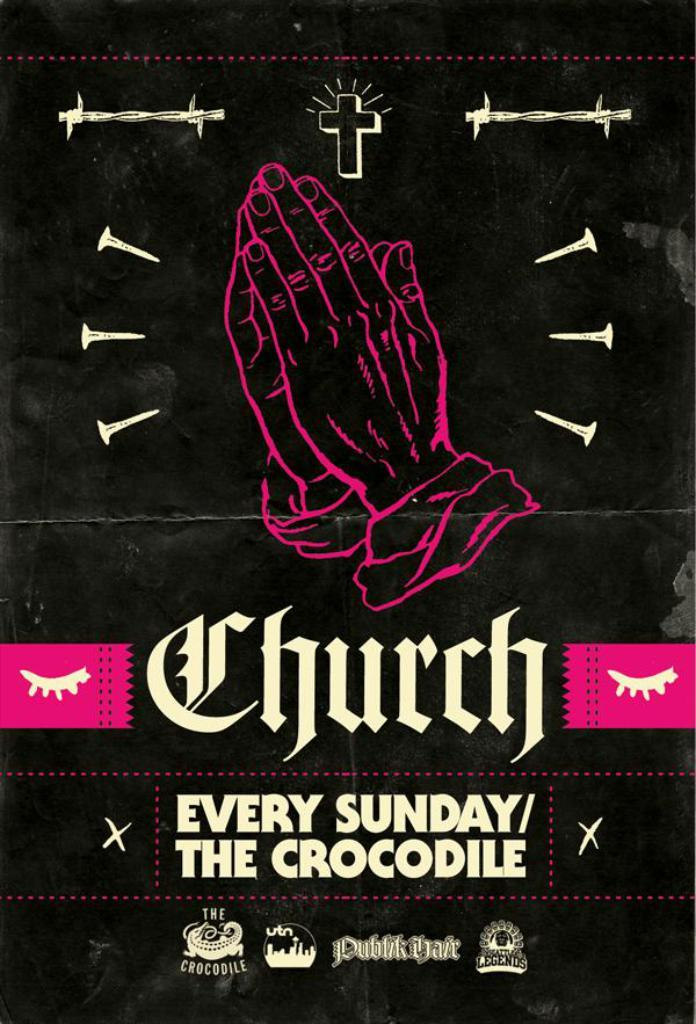What body part is visible in the image? There are a person's hands in the image. What type of markings can be seen in the image? There are symbols in the image. What type of written language is present in the image? There is text in the image. What type of grain is being harvested in the image? There is no grain or harvesting activity present in the image. 